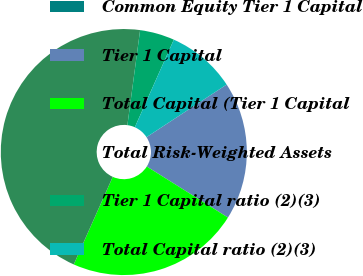<chart> <loc_0><loc_0><loc_500><loc_500><pie_chart><fcel>Common Equity Tier 1 Capital<fcel>Tier 1 Capital<fcel>Total Capital (Tier 1 Capital<fcel>Total Risk-Weighted Assets<fcel>Tier 1 Capital ratio (2)(3)<fcel>Total Capital ratio (2)(3)<nl><fcel>0.0%<fcel>18.18%<fcel>22.73%<fcel>45.45%<fcel>4.55%<fcel>9.09%<nl></chart> 